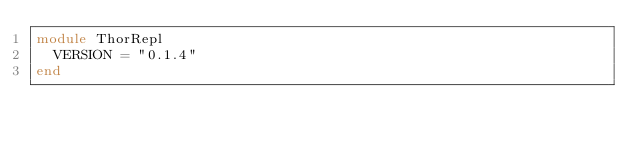<code> <loc_0><loc_0><loc_500><loc_500><_Ruby_>module ThorRepl
  VERSION = "0.1.4"
end
</code> 